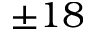<formula> <loc_0><loc_0><loc_500><loc_500>\pm 1 8</formula> 